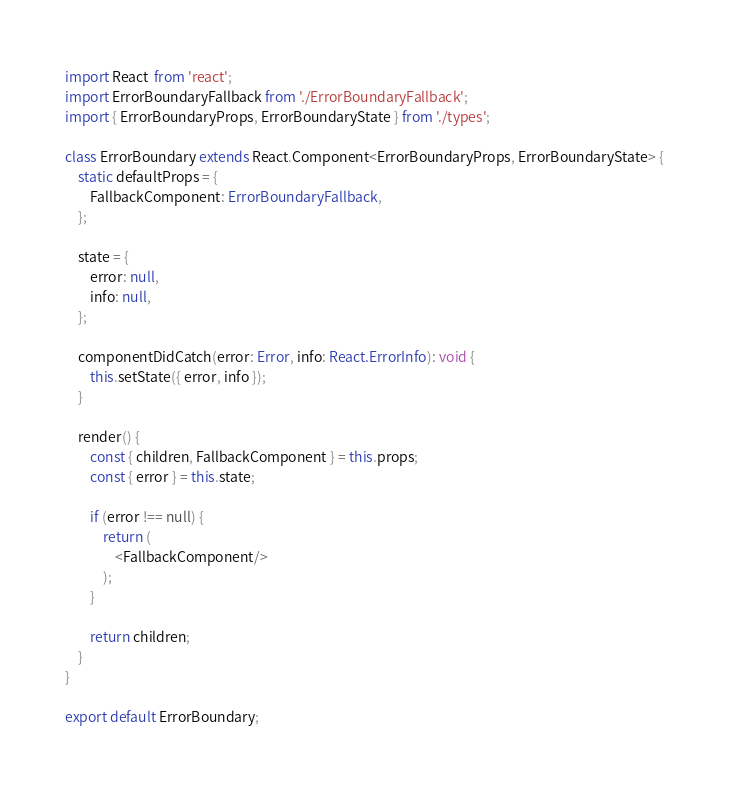Convert code to text. <code><loc_0><loc_0><loc_500><loc_500><_TypeScript_>import React  from 'react';
import ErrorBoundaryFallback from './ErrorBoundaryFallback';
import { ErrorBoundaryProps, ErrorBoundaryState } from './types';

class ErrorBoundary extends React.Component<ErrorBoundaryProps, ErrorBoundaryState> {
    static defaultProps = {
        FallbackComponent: ErrorBoundaryFallback,
    };

    state = {
        error: null,
        info: null,
    };

    componentDidCatch(error: Error, info: React.ErrorInfo): void {
        this.setState({ error, info });
    }

    render() {
        const { children, FallbackComponent } = this.props;
        const { error } = this.state;

        if (error !== null) {
            return (
                <FallbackComponent/>
            );
        }

        return children;
    }
}

export default ErrorBoundary;
</code> 